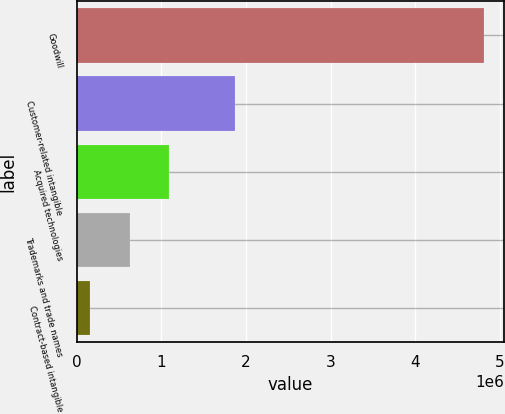Convert chart to OTSL. <chart><loc_0><loc_0><loc_500><loc_500><bar_chart><fcel>Goodwill<fcel>Customer-related intangible<fcel>Acquired technologies<fcel>Trademarks and trade names<fcel>Contract-based intangible<nl><fcel>4.80759e+06<fcel>1.86473e+06<fcel>1.08782e+06<fcel>622853<fcel>157882<nl></chart> 